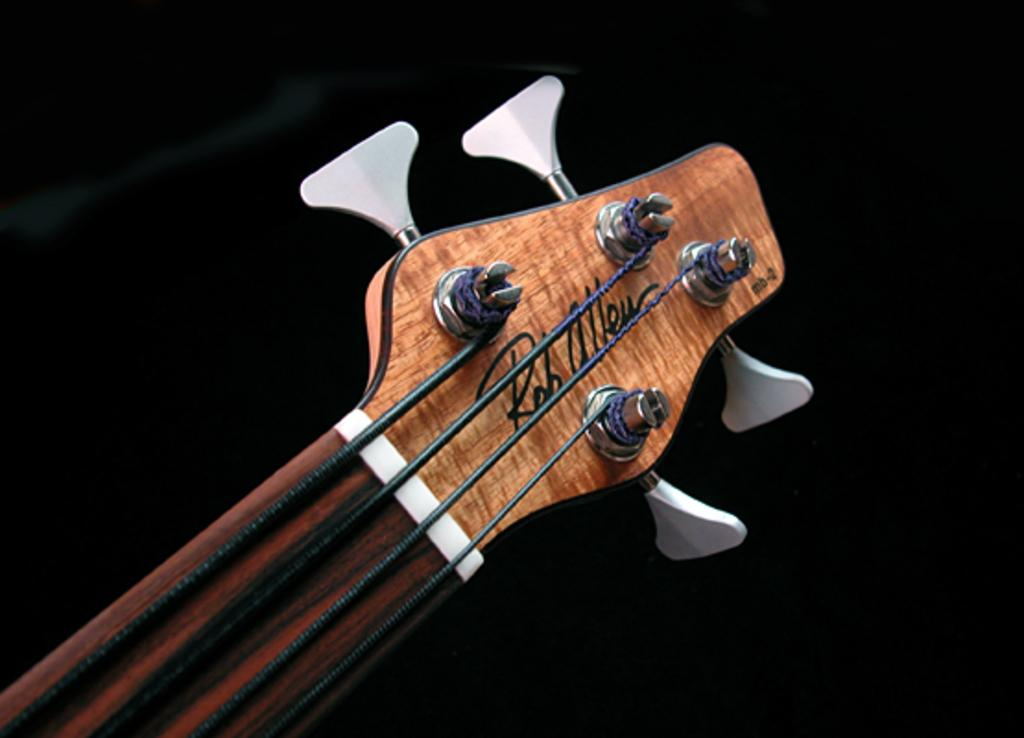What musical instrument is present in the image? There is a guitar in the image. Is there any text or label on the guitar? Yes, the label "ROHALLEU" is written on the guitar. What type of cemetery can be seen in the background of the image? There is no cemetery present in the image; it only features a guitar with the label "ROHALLEU." 